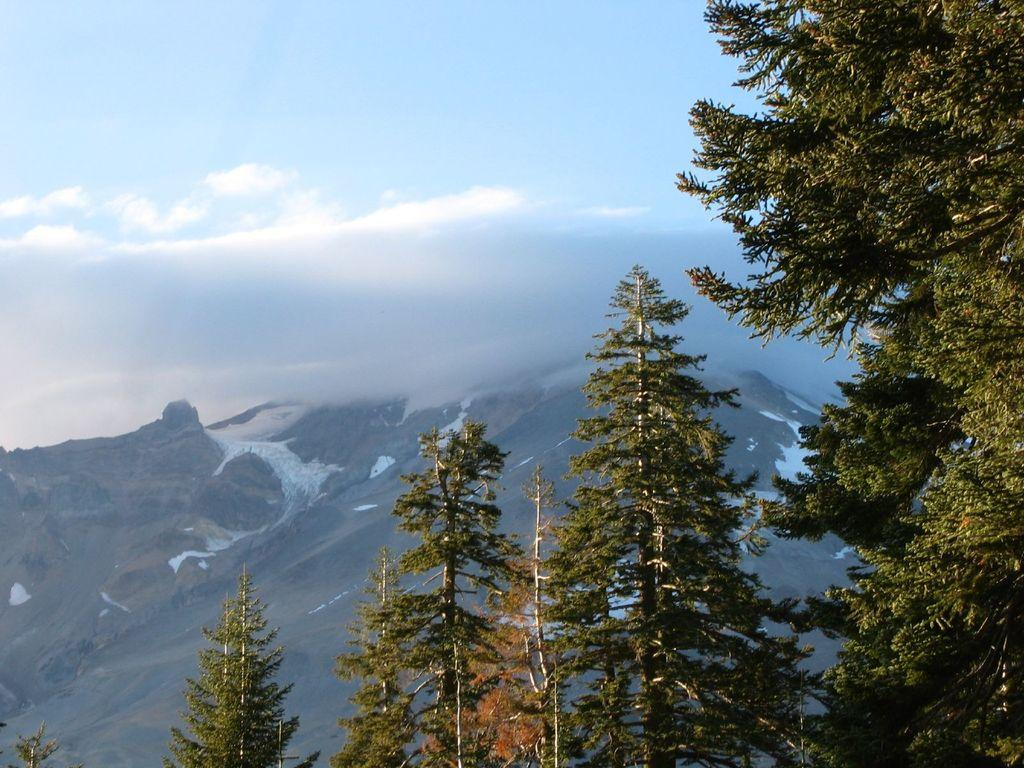What type of vegetation can be seen in the image? There are trees in the image. What geographical feature is visible in the distance? There are snowy mountains in the image. What part of the natural environment is visible in the background of the image? The sky is visible in the background of the image. What type of rail system can be seen in the image? There is no rail system present in the image. What emotion might the trees be feeling in the image? Trees do not have emotions, so it is not possible to determine what emotion they might be feeling. 